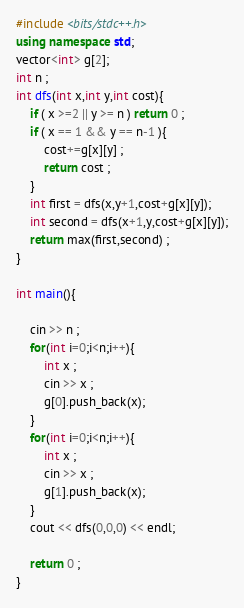Convert code to text. <code><loc_0><loc_0><loc_500><loc_500><_C++_>#include <bits/stdc++.h>
using namespace std;
vector<int> g[2];
int n ;
int dfs(int x,int y,int cost){
    if ( x >=2 || y >= n ) return 0 ;
    if ( x == 1 && y == n-1 ){
        cost+=g[x][y] ;
        return cost ;
    }
    int first = dfs(x,y+1,cost+g[x][y]);
    int second = dfs(x+1,y,cost+g[x][y]);
    return max(first,second) ;
}

int main(){

    cin >> n ;
    for(int i=0;i<n;i++){
        int x ;
        cin >> x ;
        g[0].push_back(x);
    }
    for(int i=0;i<n;i++){
        int x ;
        cin >> x ;
        g[1].push_back(x);
    }
    cout << dfs(0,0,0) << endl;

    return 0 ;
}
</code> 